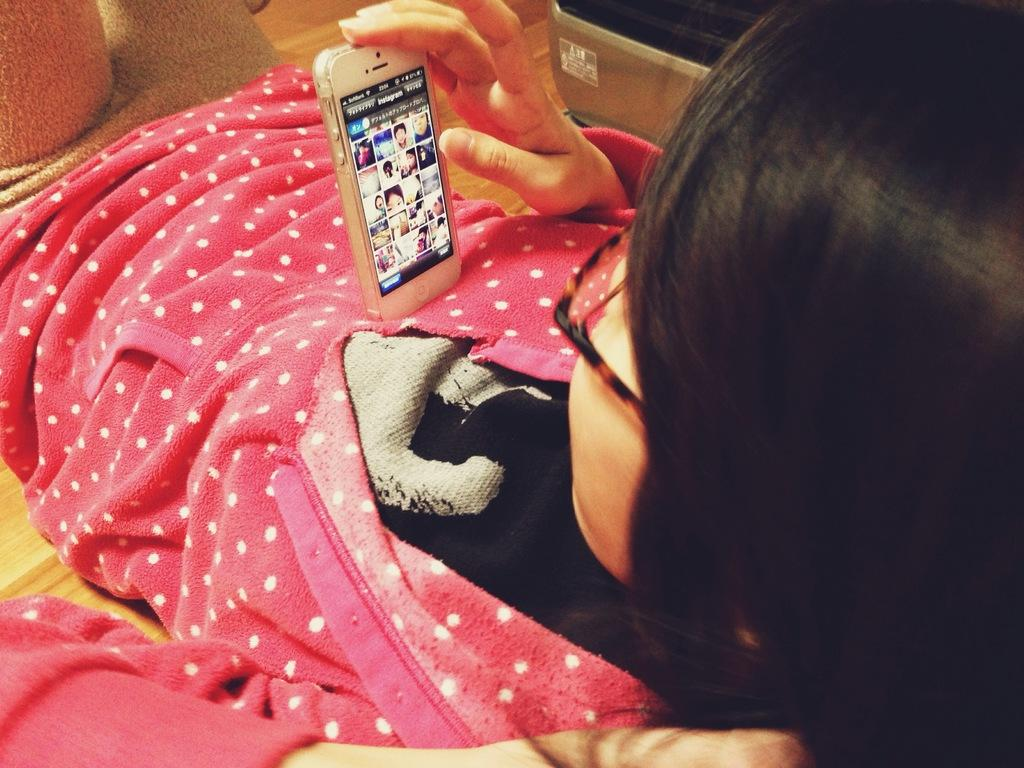Who is the main subject in the image? There is a woman in the image. What is the woman doing in the image? The woman is lying on the floor. What object is the woman holding in the image? The woman is holding a mobile. What type of flower is growing on the woman's head in the image? There is no flower present on the woman's head in the image. 